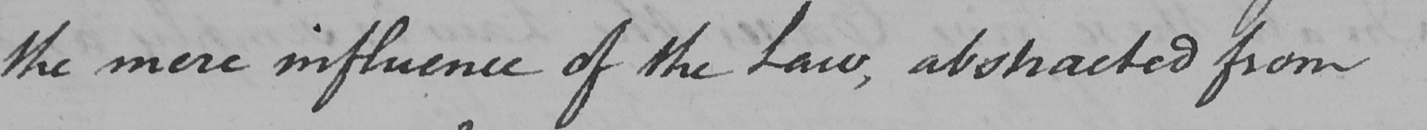Transcribe the text shown in this historical manuscript line. the mere influence of the Law , abstracted from 